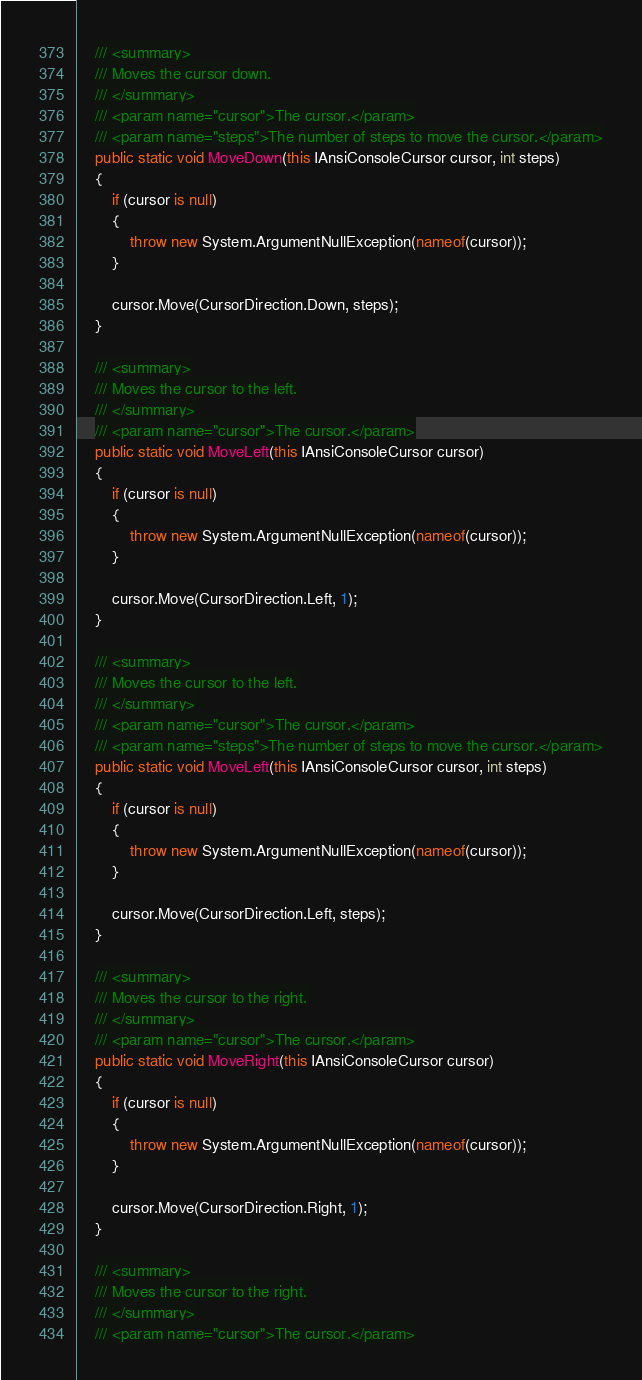Convert code to text. <code><loc_0><loc_0><loc_500><loc_500><_C#_>
    /// <summary>
    /// Moves the cursor down.
    /// </summary>
    /// <param name="cursor">The cursor.</param>
    /// <param name="steps">The number of steps to move the cursor.</param>
    public static void MoveDown(this IAnsiConsoleCursor cursor, int steps)
    {
        if (cursor is null)
        {
            throw new System.ArgumentNullException(nameof(cursor));
        }

        cursor.Move(CursorDirection.Down, steps);
    }

    /// <summary>
    /// Moves the cursor to the left.
    /// </summary>
    /// <param name="cursor">The cursor.</param>
    public static void MoveLeft(this IAnsiConsoleCursor cursor)
    {
        if (cursor is null)
        {
            throw new System.ArgumentNullException(nameof(cursor));
        }

        cursor.Move(CursorDirection.Left, 1);
    }

    /// <summary>
    /// Moves the cursor to the left.
    /// </summary>
    /// <param name="cursor">The cursor.</param>
    /// <param name="steps">The number of steps to move the cursor.</param>
    public static void MoveLeft(this IAnsiConsoleCursor cursor, int steps)
    {
        if (cursor is null)
        {
            throw new System.ArgumentNullException(nameof(cursor));
        }

        cursor.Move(CursorDirection.Left, steps);
    }

    /// <summary>
    /// Moves the cursor to the right.
    /// </summary>
    /// <param name="cursor">The cursor.</param>
    public static void MoveRight(this IAnsiConsoleCursor cursor)
    {
        if (cursor is null)
        {
            throw new System.ArgumentNullException(nameof(cursor));
        }

        cursor.Move(CursorDirection.Right, 1);
    }

    /// <summary>
    /// Moves the cursor to the right.
    /// </summary>
    /// <param name="cursor">The cursor.</param></code> 